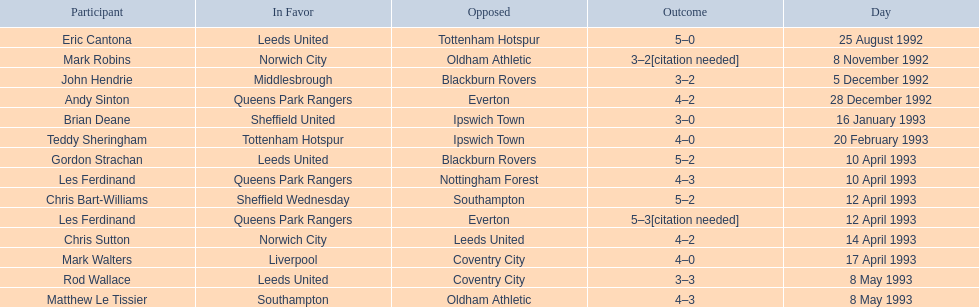Who are the players in 1992-93 fa premier league? Eric Cantona, Mark Robins, John Hendrie, Andy Sinton, Brian Deane, Teddy Sheringham, Gordon Strachan, Les Ferdinand, Chris Bart-Williams, Les Ferdinand, Chris Sutton, Mark Walters, Rod Wallace, Matthew Le Tissier. What is mark robins' result? 3–2[citation needed]. Which player has the same result? John Hendrie. 